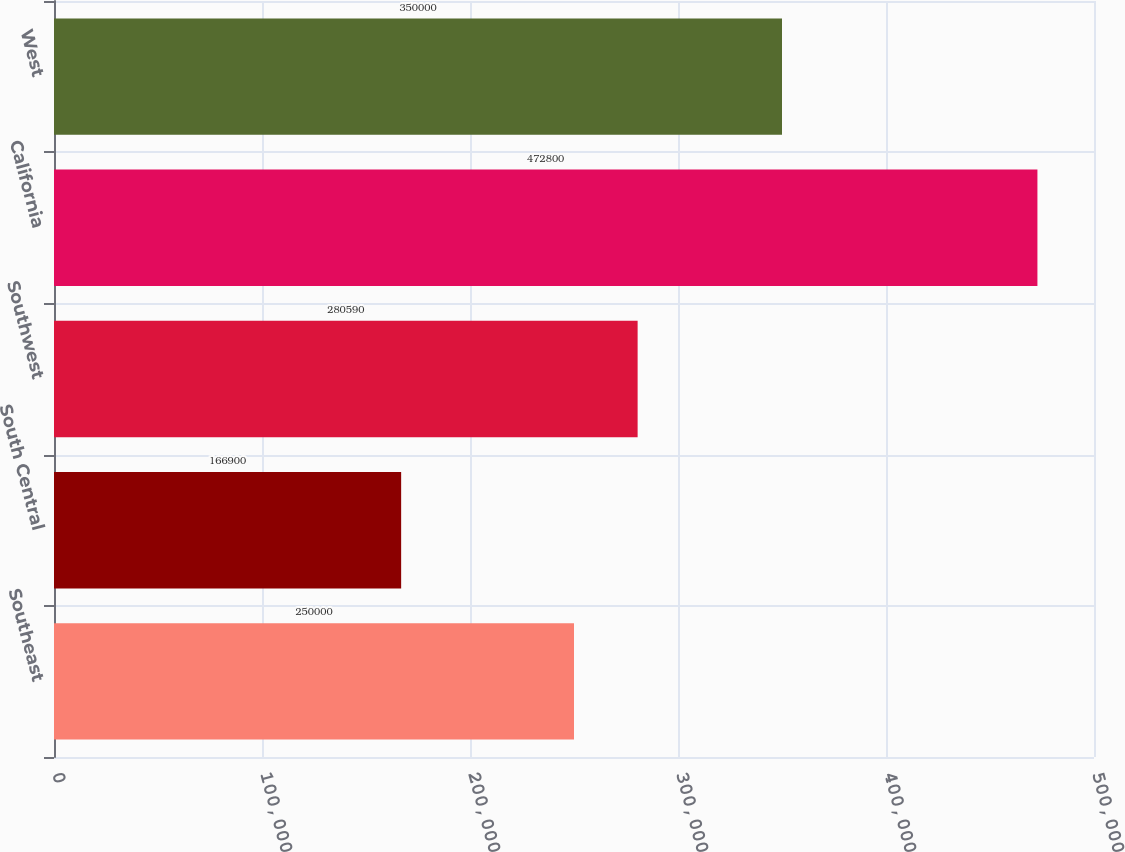Convert chart. <chart><loc_0><loc_0><loc_500><loc_500><bar_chart><fcel>Southeast<fcel>South Central<fcel>Southwest<fcel>California<fcel>West<nl><fcel>250000<fcel>166900<fcel>280590<fcel>472800<fcel>350000<nl></chart> 